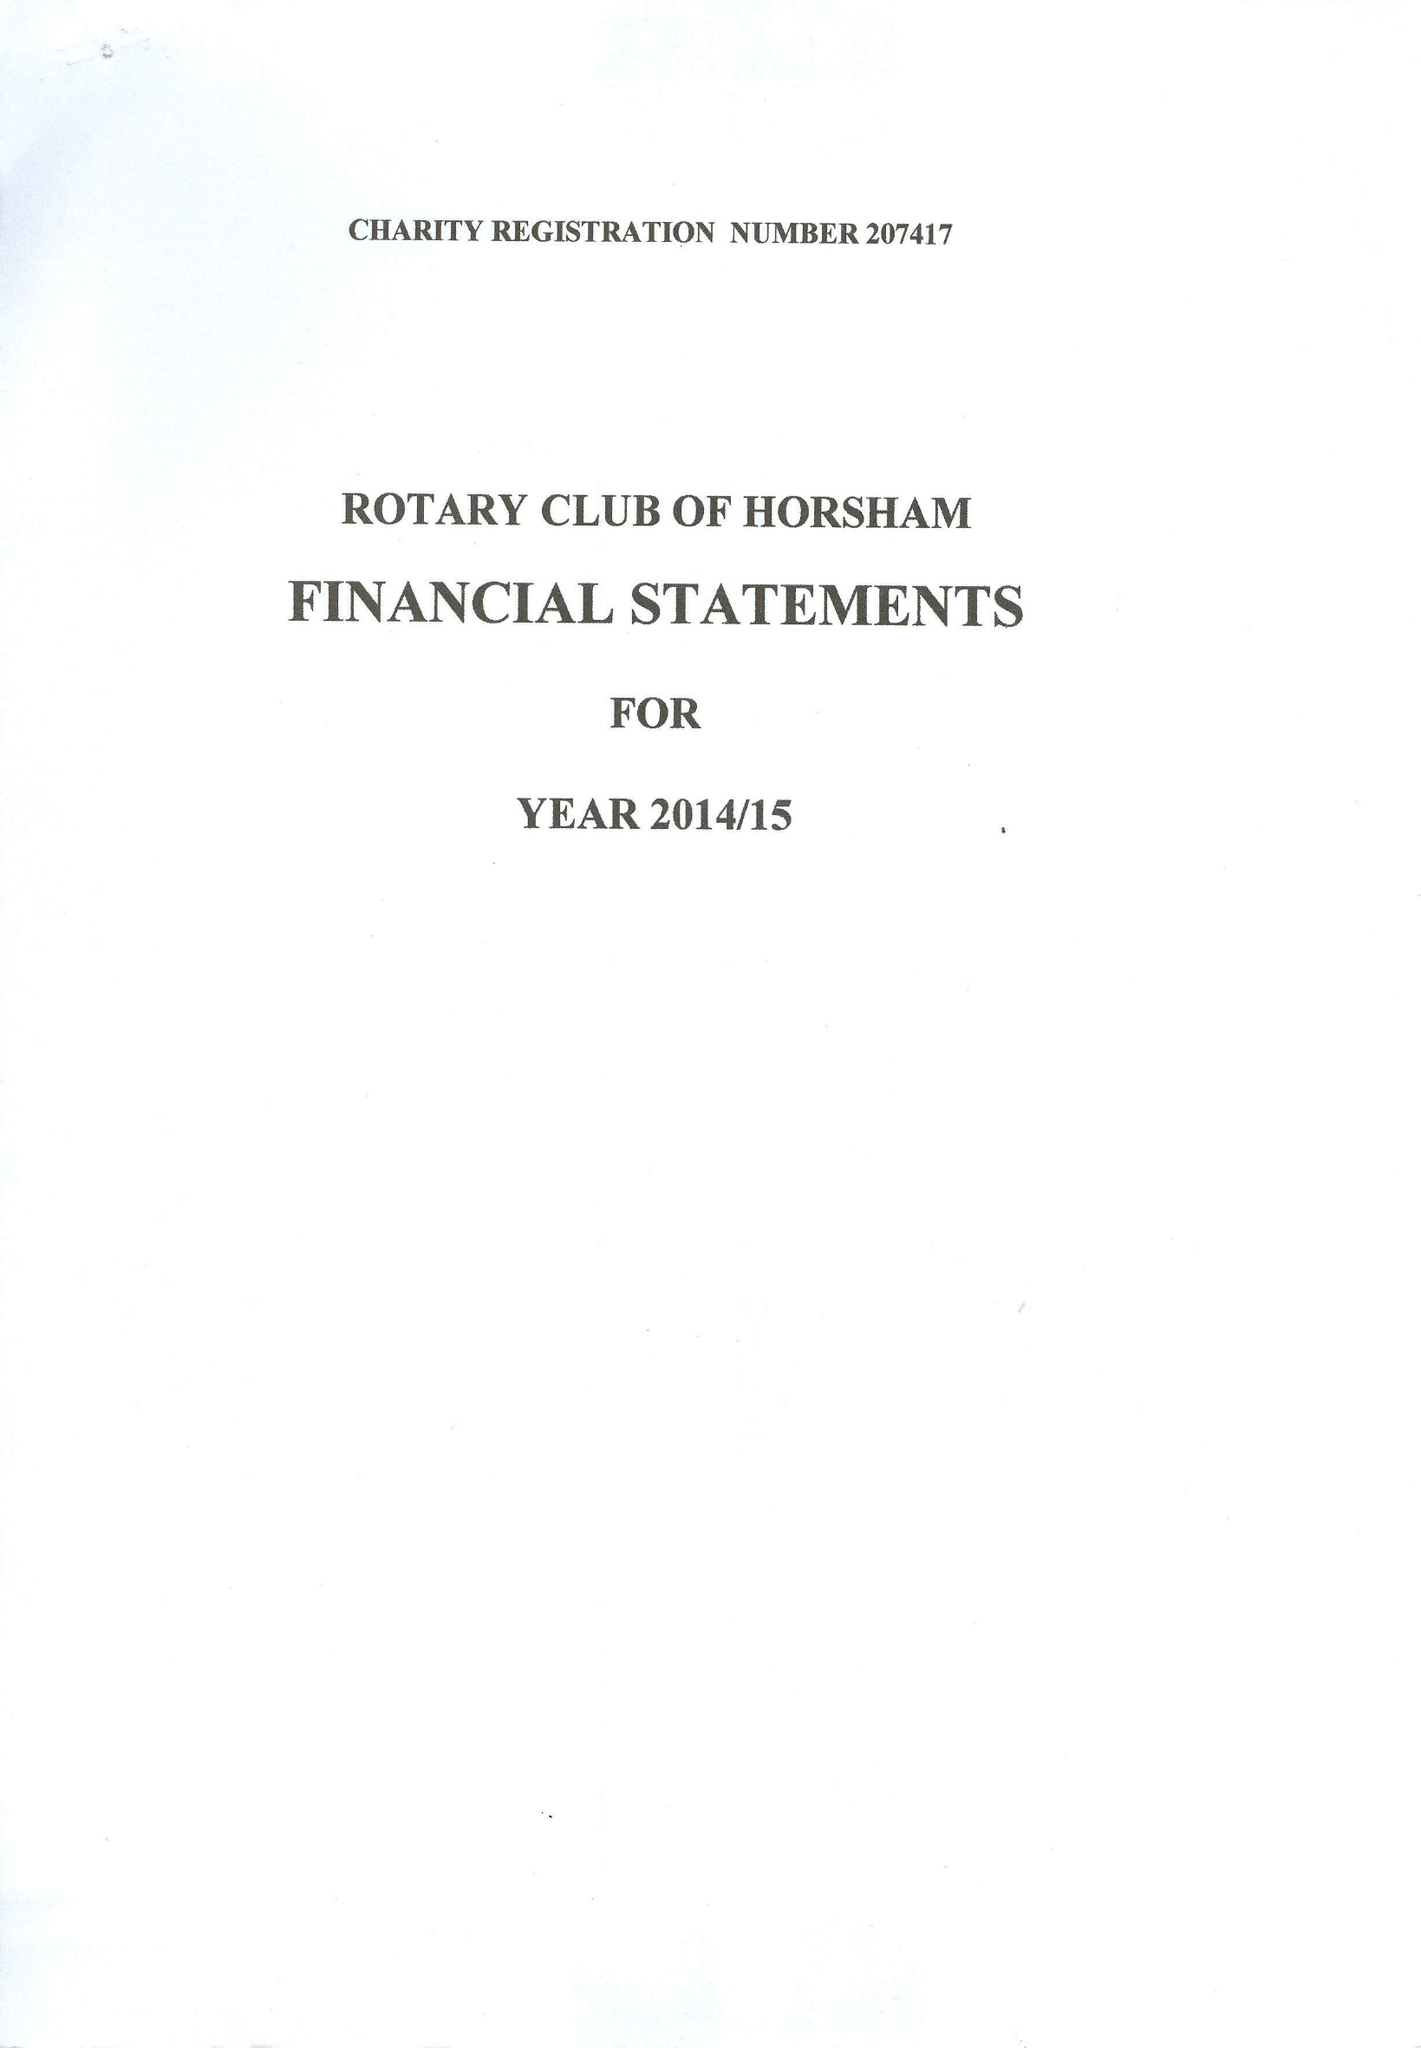What is the value for the spending_annually_in_british_pounds?
Answer the question using a single word or phrase. 41275.00 